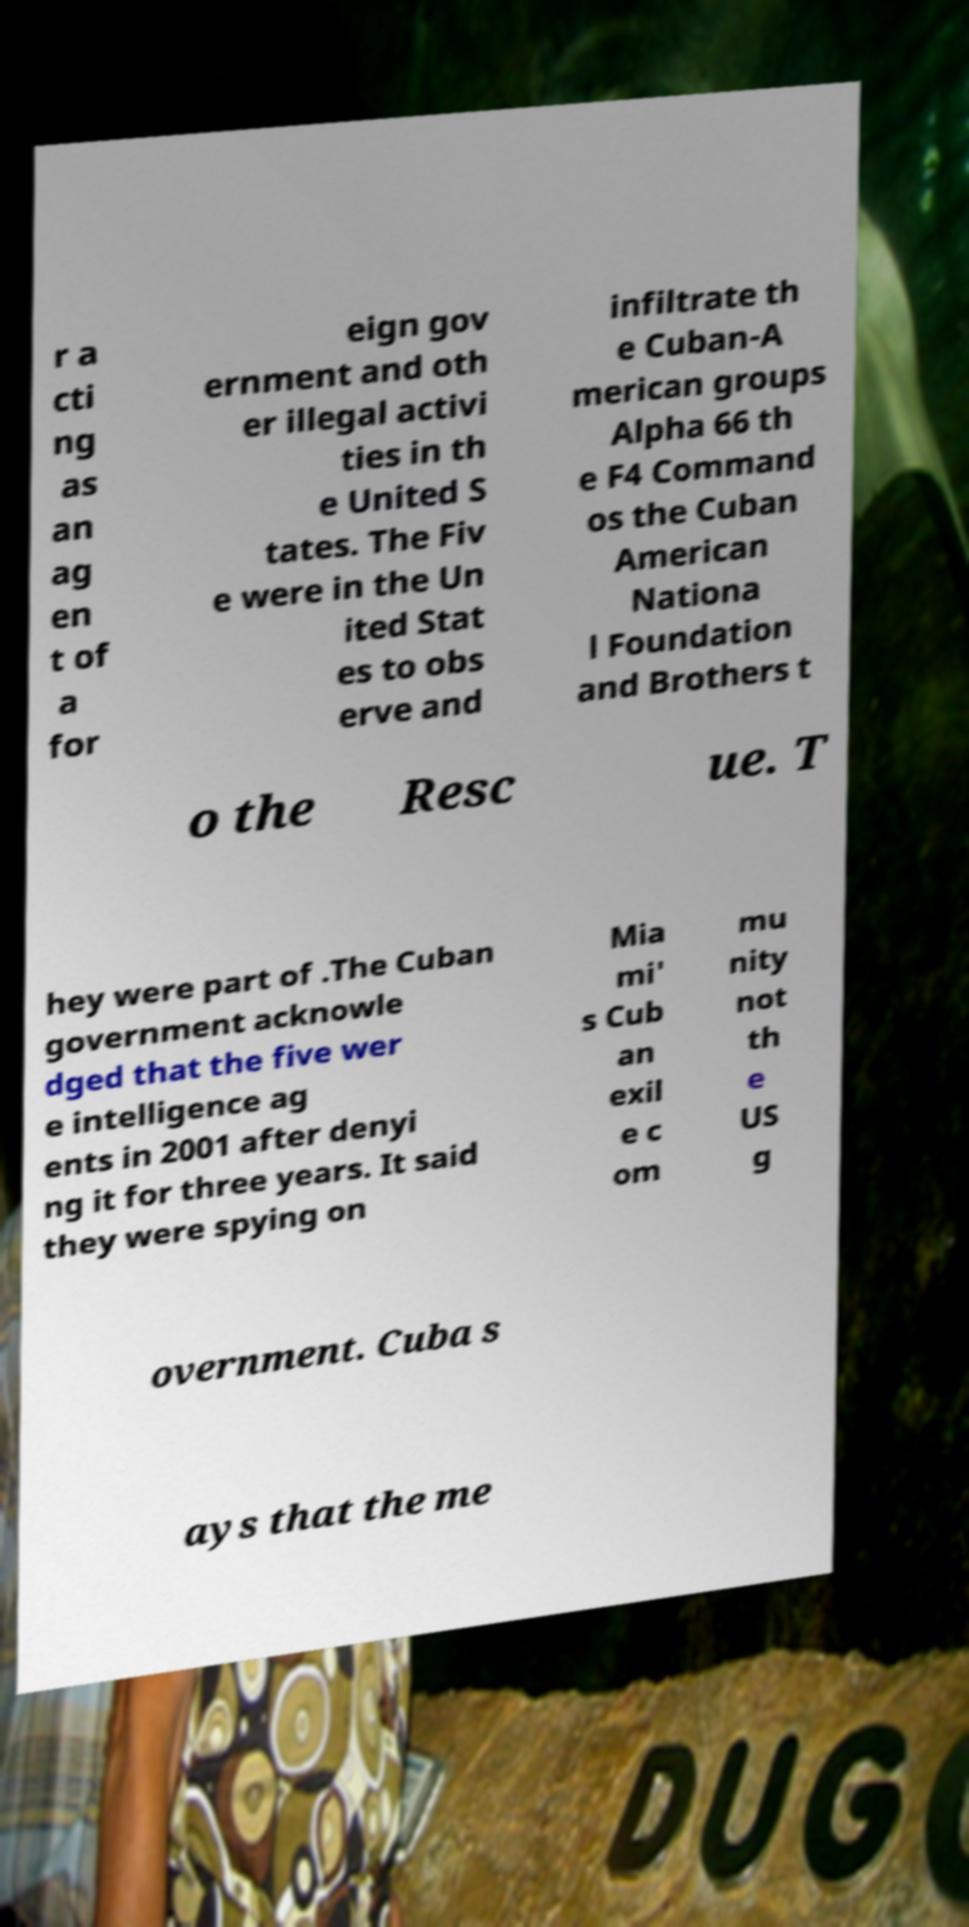There's text embedded in this image that I need extracted. Can you transcribe it verbatim? r a cti ng as an ag en t of a for eign gov ernment and oth er illegal activi ties in th e United S tates. The Fiv e were in the Un ited Stat es to obs erve and infiltrate th e Cuban-A merican groups Alpha 66 th e F4 Command os the Cuban American Nationa l Foundation and Brothers t o the Resc ue. T hey were part of .The Cuban government acknowle dged that the five wer e intelligence ag ents in 2001 after denyi ng it for three years. It said they were spying on Mia mi' s Cub an exil e c om mu nity not th e US g overnment. Cuba s ays that the me 